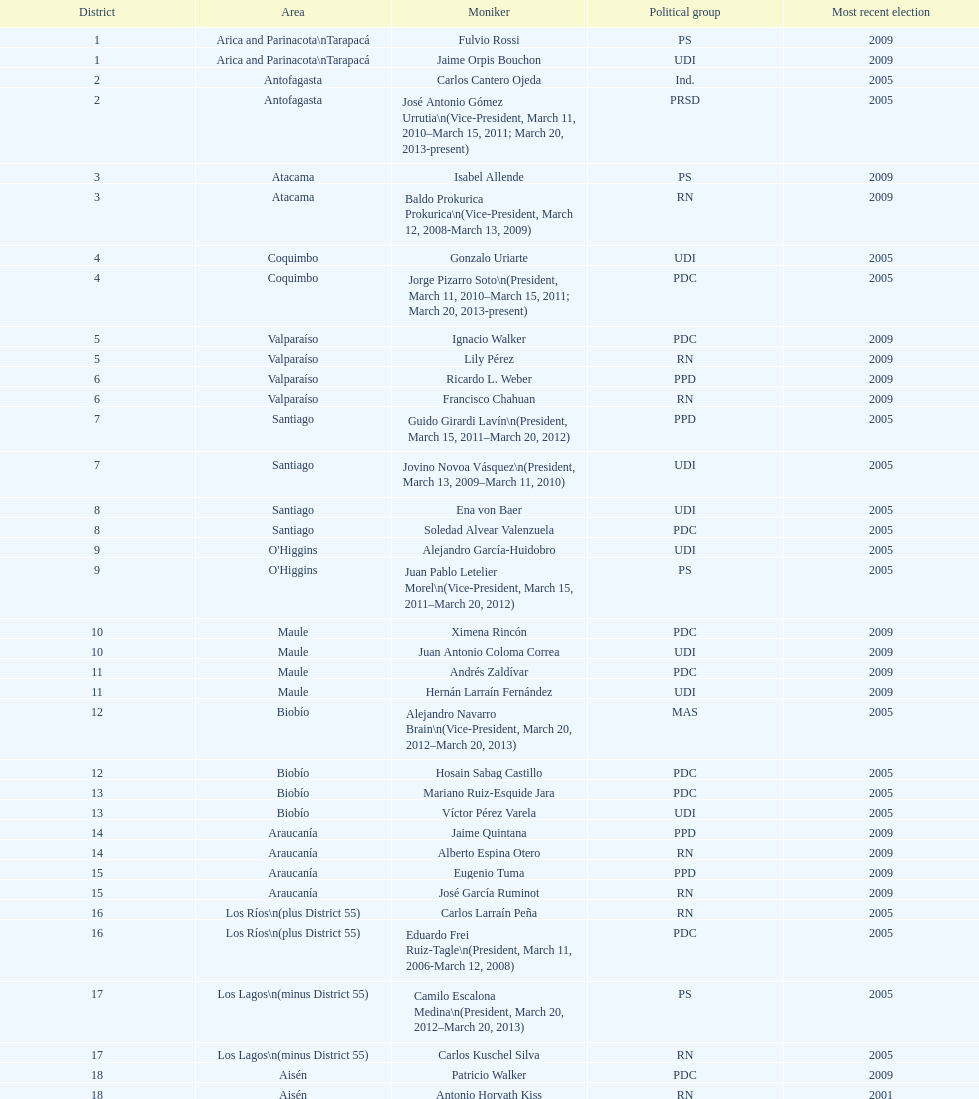How long was baldo prokurica prokurica vice-president? 1 year. 